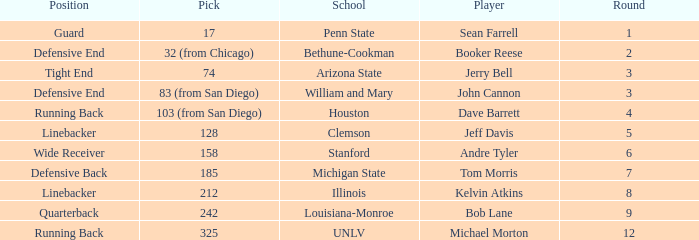What choice did clemson opt for? 128.0. 